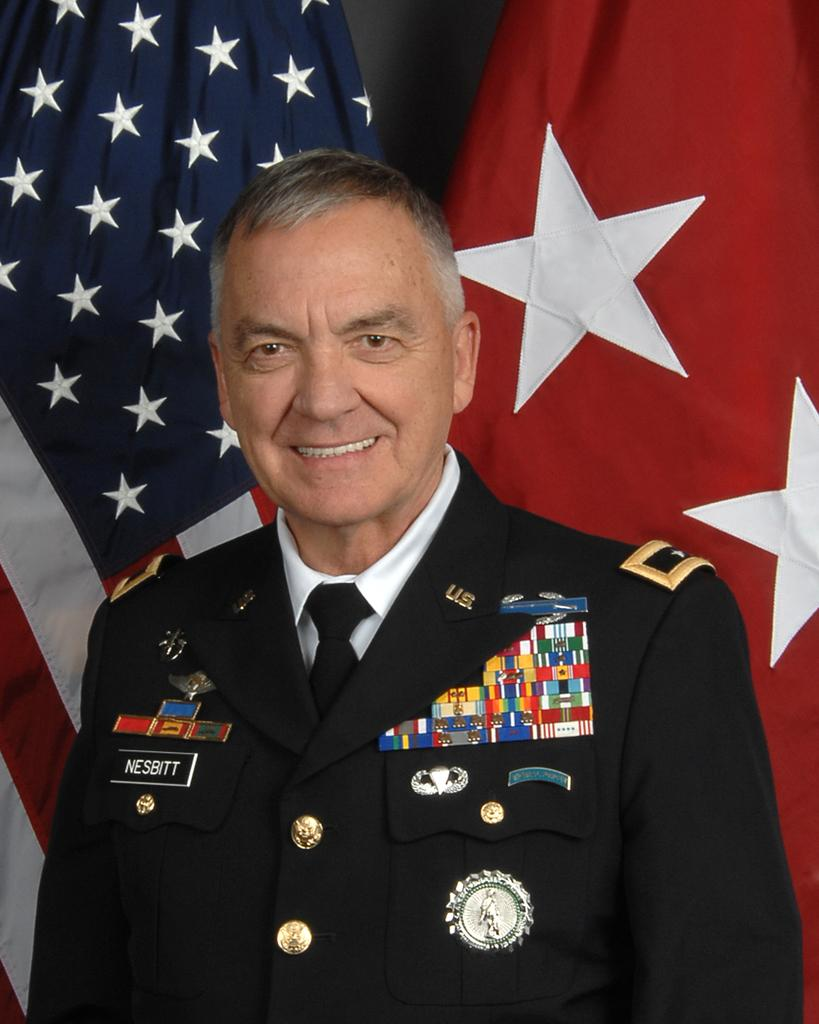What is the main subject of the image? There is a person in the image. What is the person wearing? The person is wearing a black suit. Are there any additional features on the suit? Yes, there are objects attached to the suit. What can be seen in the background of the image? There are two flags behind the person. What type of feather can be seen on the person's hat in the image? There is no hat or feather present in the image. Is the person in the image a coal miner? There is no information in the image to suggest that the person is a coal miner. 